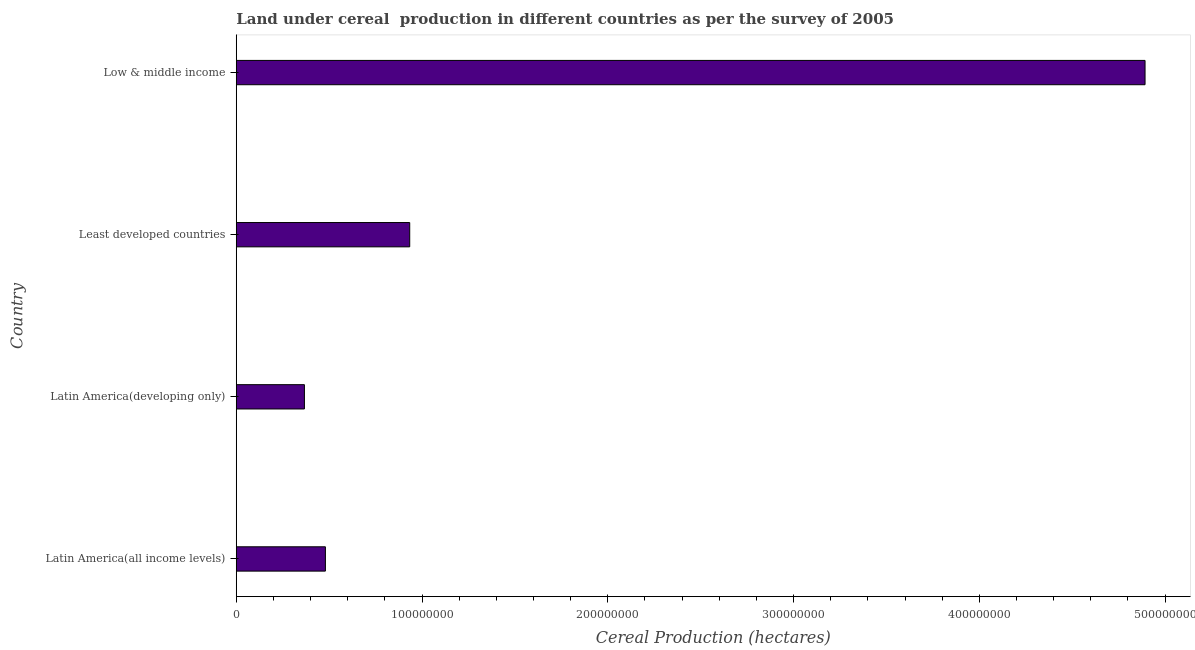Does the graph contain any zero values?
Your answer should be compact. No. What is the title of the graph?
Provide a short and direct response. Land under cereal  production in different countries as per the survey of 2005. What is the label or title of the X-axis?
Give a very brief answer. Cereal Production (hectares). What is the label or title of the Y-axis?
Your answer should be very brief. Country. What is the land under cereal production in Least developed countries?
Provide a succinct answer. 9.34e+07. Across all countries, what is the maximum land under cereal production?
Your response must be concise. 4.89e+08. Across all countries, what is the minimum land under cereal production?
Your answer should be very brief. 3.67e+07. In which country was the land under cereal production minimum?
Provide a short and direct response. Latin America(developing only). What is the sum of the land under cereal production?
Your response must be concise. 6.67e+08. What is the difference between the land under cereal production in Least developed countries and Low & middle income?
Ensure brevity in your answer.  -3.96e+08. What is the average land under cereal production per country?
Offer a very short reply. 1.67e+08. What is the median land under cereal production?
Ensure brevity in your answer.  7.07e+07. In how many countries, is the land under cereal production greater than 20000000 hectares?
Make the answer very short. 4. What is the ratio of the land under cereal production in Latin America(developing only) to that in Least developed countries?
Your answer should be very brief. 0.39. Is the land under cereal production in Latin America(all income levels) less than that in Latin America(developing only)?
Give a very brief answer. No. What is the difference between the highest and the second highest land under cereal production?
Your response must be concise. 3.96e+08. Is the sum of the land under cereal production in Latin America(developing only) and Low & middle income greater than the maximum land under cereal production across all countries?
Your answer should be very brief. Yes. What is the difference between the highest and the lowest land under cereal production?
Provide a short and direct response. 4.53e+08. How many bars are there?
Give a very brief answer. 4. Are all the bars in the graph horizontal?
Provide a short and direct response. Yes. What is the difference between two consecutive major ticks on the X-axis?
Give a very brief answer. 1.00e+08. What is the Cereal Production (hectares) in Latin America(all income levels)?
Provide a short and direct response. 4.80e+07. What is the Cereal Production (hectares) of Latin America(developing only)?
Make the answer very short. 3.67e+07. What is the Cereal Production (hectares) of Least developed countries?
Your answer should be compact. 9.34e+07. What is the Cereal Production (hectares) of Low & middle income?
Your answer should be compact. 4.89e+08. What is the difference between the Cereal Production (hectares) in Latin America(all income levels) and Latin America(developing only)?
Keep it short and to the point. 1.13e+07. What is the difference between the Cereal Production (hectares) in Latin America(all income levels) and Least developed countries?
Provide a short and direct response. -4.54e+07. What is the difference between the Cereal Production (hectares) in Latin America(all income levels) and Low & middle income?
Keep it short and to the point. -4.41e+08. What is the difference between the Cereal Production (hectares) in Latin America(developing only) and Least developed countries?
Your answer should be very brief. -5.67e+07. What is the difference between the Cereal Production (hectares) in Latin America(developing only) and Low & middle income?
Your response must be concise. -4.53e+08. What is the difference between the Cereal Production (hectares) in Least developed countries and Low & middle income?
Your response must be concise. -3.96e+08. What is the ratio of the Cereal Production (hectares) in Latin America(all income levels) to that in Latin America(developing only)?
Provide a succinct answer. 1.31. What is the ratio of the Cereal Production (hectares) in Latin America(all income levels) to that in Least developed countries?
Provide a succinct answer. 0.51. What is the ratio of the Cereal Production (hectares) in Latin America(all income levels) to that in Low & middle income?
Provide a succinct answer. 0.1. What is the ratio of the Cereal Production (hectares) in Latin America(developing only) to that in Least developed countries?
Your response must be concise. 0.39. What is the ratio of the Cereal Production (hectares) in Latin America(developing only) to that in Low & middle income?
Ensure brevity in your answer.  0.07. What is the ratio of the Cereal Production (hectares) in Least developed countries to that in Low & middle income?
Your answer should be very brief. 0.19. 